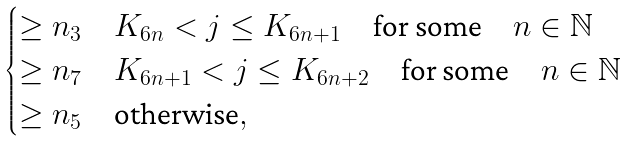<formula> <loc_0><loc_0><loc_500><loc_500>\begin{cases} \geq n _ { 3 } & K _ { 6 n } < j \leq K _ { 6 n + 1 } \quad \text {for some} \quad n \in \mathbb { N } \\ \geq n _ { 7 } & K _ { 6 n + 1 } < j \leq K _ { 6 n + 2 } \quad \text {for some} \quad n \in \mathbb { N } \\ \geq n _ { 5 } & \text {otherwise} , \end{cases}</formula> 